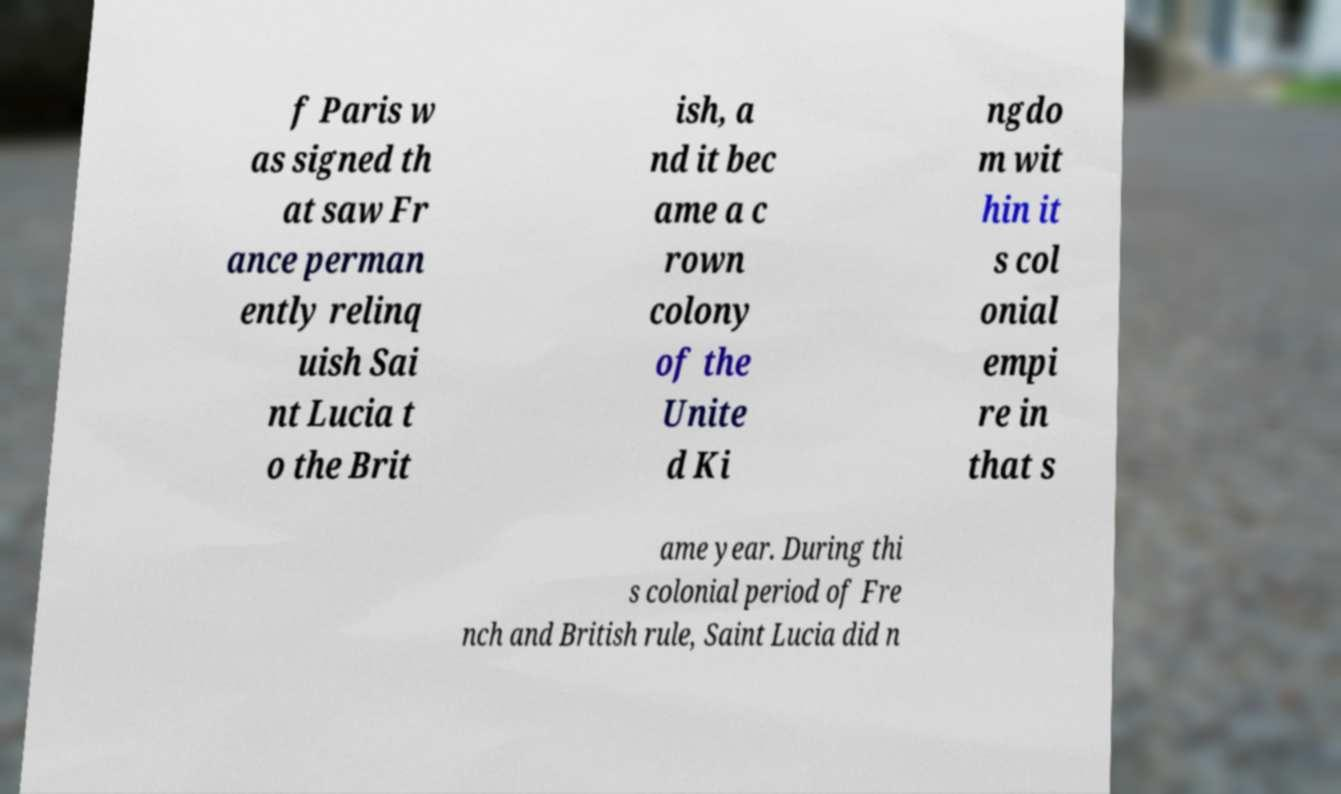For documentation purposes, I need the text within this image transcribed. Could you provide that? f Paris w as signed th at saw Fr ance perman ently relinq uish Sai nt Lucia t o the Brit ish, a nd it bec ame a c rown colony of the Unite d Ki ngdo m wit hin it s col onial empi re in that s ame year. During thi s colonial period of Fre nch and British rule, Saint Lucia did n 